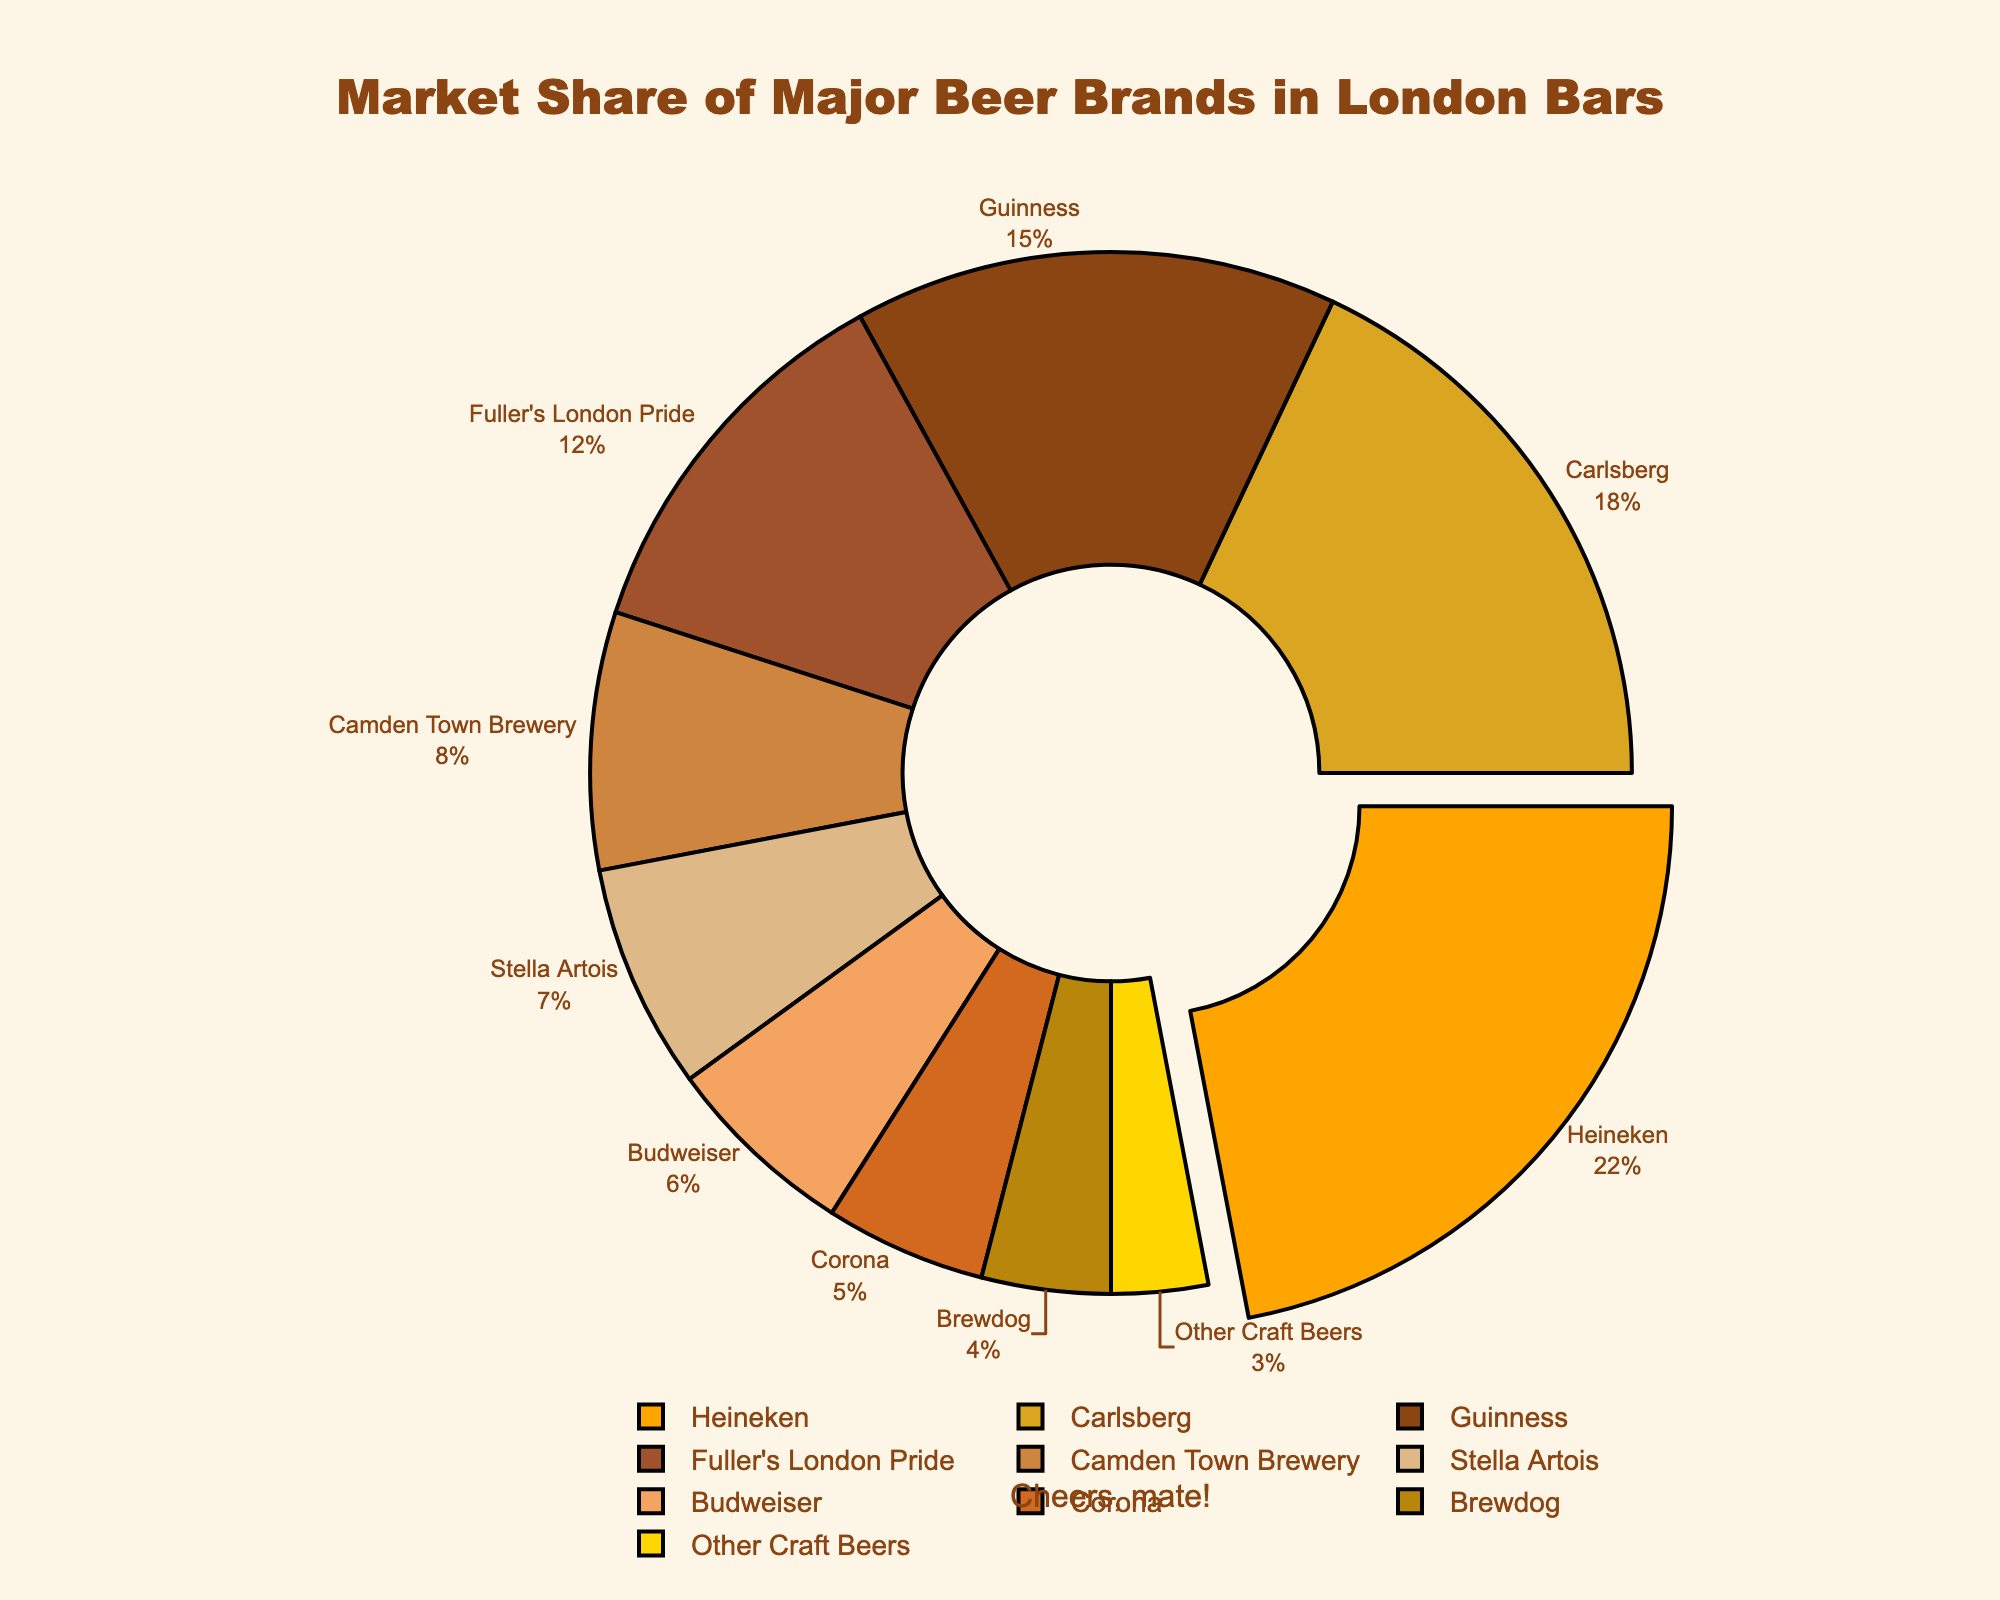What's the total market share of Heineken and Carlsberg? Heineken has 22% and Carlsberg has 18%. Adding these together gives 22% + 18% = 40%.
Answer: 40% Which brand has the largest market share? Heineken has the largest market share, as it's pulled out from the pie chart and prominently displayed.
Answer: Heineken What is the visual position of the brand with the smallest market share? The brand with the smallest market share, 3%, is "Other Craft Beers." It is a small segment of the pie chart, visually located on the top-right edge outside of the central hole.
Answer: Top-right edge Compare the market share of Guinness and Fuller's London Pride. Which one is larger? Guinness has a market share of 15%, and Fuller's London Pride has 12%. Therefore, Guinness's market share is larger.
Answer: Guinness How much more market share does Guinness have compared to Corona? Guinness has 15% and Corona has 5%. The difference is 15% - 5% = 10%.
Answer: 10% What percentage of the market share is held by local brands (Fuller's London Pride and Camden Town Brewery)? Fuller's London Pride has 12% and Camden Town Brewery has 8%. The total is 12% + 8% = 20%.
Answer: 20% Is the combined market share of Stella Artois and Budweiser less than that of Carlsberg? Stella Artois has 7% and Budweiser has 6%, their combined market share is 7% + 6% = 13%. Carlsberg alone has 18%, which is larger than 13%.
Answer: Yes What is the average market share of Heineken, Carlsberg, and Guinness? Adding their market shares: 22% (Heineken) + 18% (Carlsberg) + 15% (Guinness) = 55%. Dividing by 3 gives 55% / 3 ≈ 18.33%.
Answer: 18.33% Which brand appears between Heineken and Camden Town Brewery in terms of market share? Fuller's London Pride, with 12%, appears between Heineken (22%) and Camden Town Brewery (8%) in terms of market share.
Answer: Fuller's London Pride 